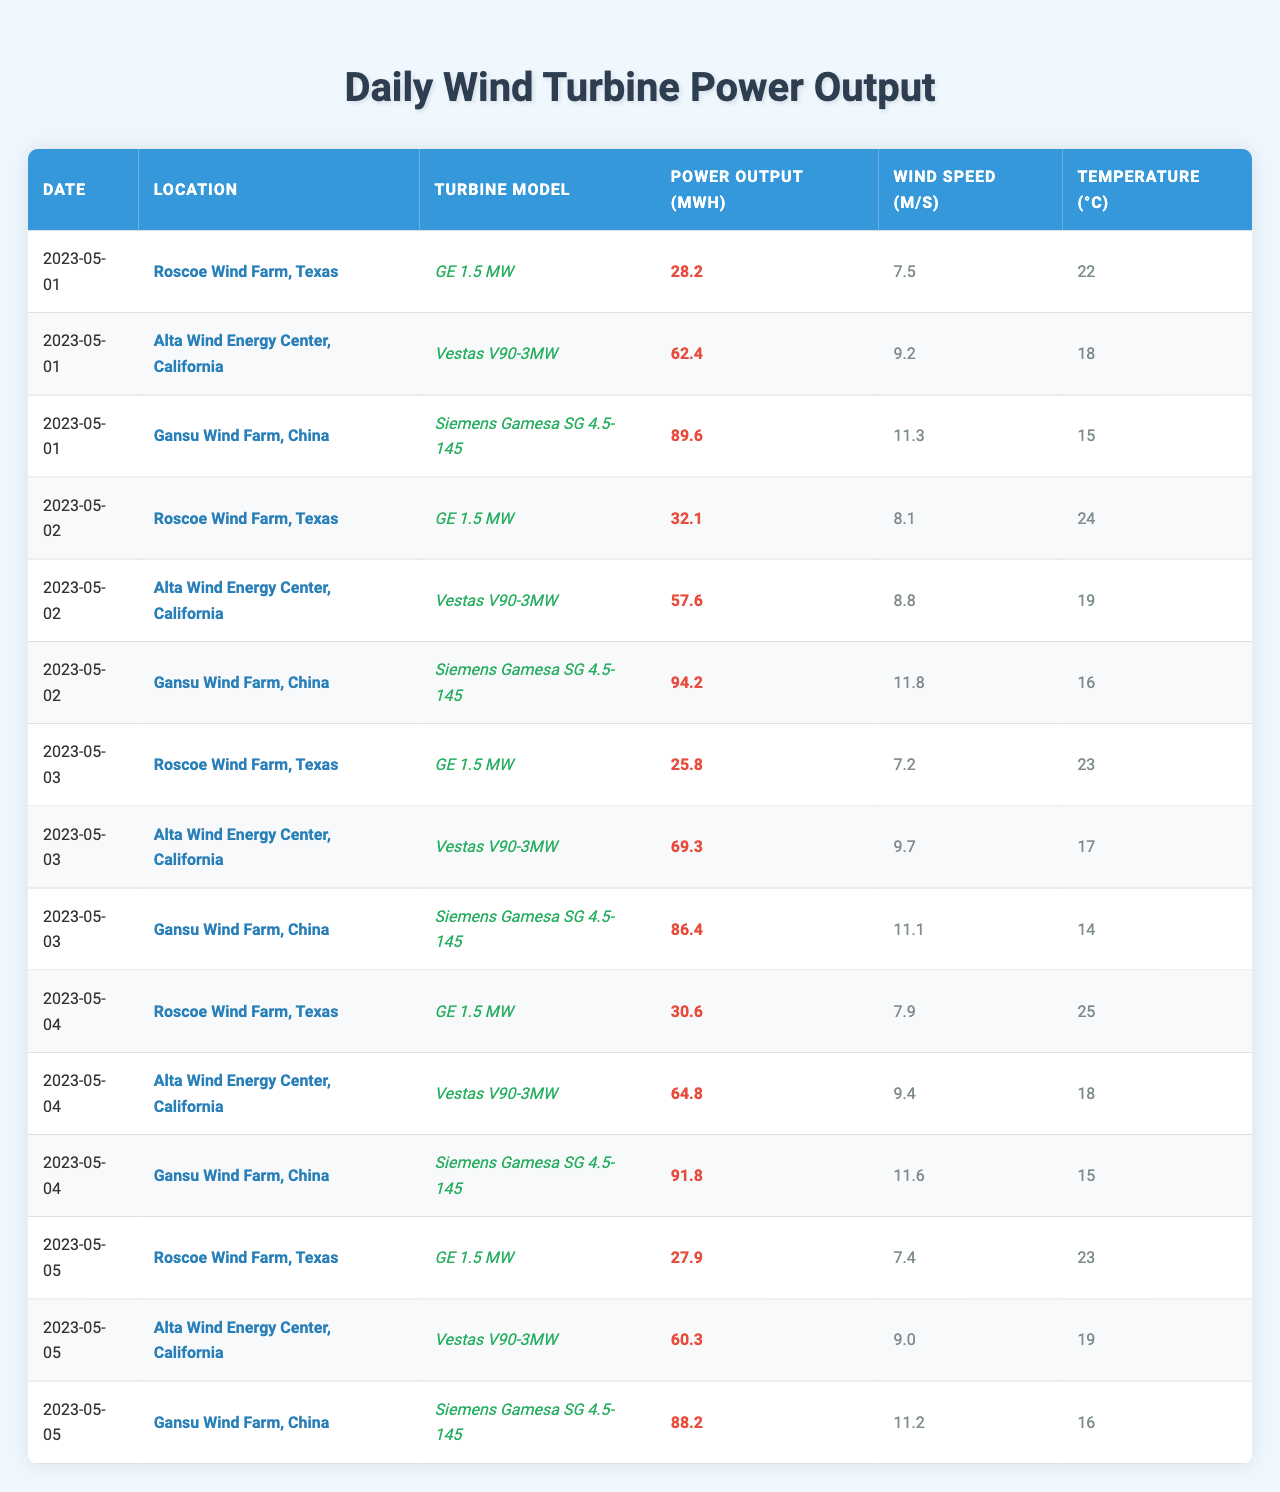What is the highest power output recorded in the table? Looking through the "Power Output (MWh)" column, the highest value is 94.2 on May 2 at the Gansu Wind Farm, China.
Answer: 94.2 How many days are recorded in the table? The data includes power output for 5 distinct days (May 1 to May 5, 2023).
Answer: 5 Which turbine model had the lowest power output on May 3? On May 3, the GE 1.5 MW model at Roscoe Wind Farm had a power output of 25.8 MWh, which is the lowest on that day.
Answer: GE 1.5 MW What is the average power output for the Alta Wind Energy Center? The total power outputs for Alta Wind Energy Center over 5 days are (62.4 + 57.6 + 69.3 + 64.8 + 60.3) = 314.4 MWh. Dividing this by 5 gives an average of 62.88 MWh.
Answer: 62.88 Did the power output increase or decrease from May 2 to May 3 at Gansu Wind Farm? On May 2, Gansu Wind Farm produced 94.2 MWh, while on May 3 it produced 86.4 MWh. Since 86.4 is less than 94.2, the output decreased.
Answer: Decreased Which location had the highest power output on May 1? On May 1, the Gansu Wind Farm recorded the highest output of 89.6 MWh, compared to the other two locations.
Answer: Gansu Wind Farm What was the average wind speed for the Roscoe Wind Farm during this period? The wind speeds recorded for Roscoe Wind Farm over 5 days were (7.5 + 8.1 + 7.2 + 7.9 + 7.4) = 38.1 m/s. The average is 38.1 / 5 = 7.62 m/s.
Answer: 7.62 m/s Did both wind farms in Texas have consistently increasing power outputs over the 5 days? Checking the power outputs for Roscoe Wind Farm: 28.2, 32.1, 25.8, 30.6, 27.9, they do not show a consistent increase as there's a drop on May 3. Therefore, it's not consistent.
Answer: No What is the relationship between wind speed and power output at Alta Wind Energy Center? Analyzing the data shows that as the wind speed varied between 8.8 m/s and 9.7 m/s, the power output fluctuated from 57.6 to 69.3 MWh, indicating a positive correlation where higher speeds tend to correlate with higher outputs.
Answer: Positive correlation How much power did Gansu Wind Farm produce across all days recorded? Adding the power output for Gansu: 89.6 + 94.2 + 86.4 + 91.8 + 88.2 = 450.2 MWh.
Answer: 450.2 MWh 